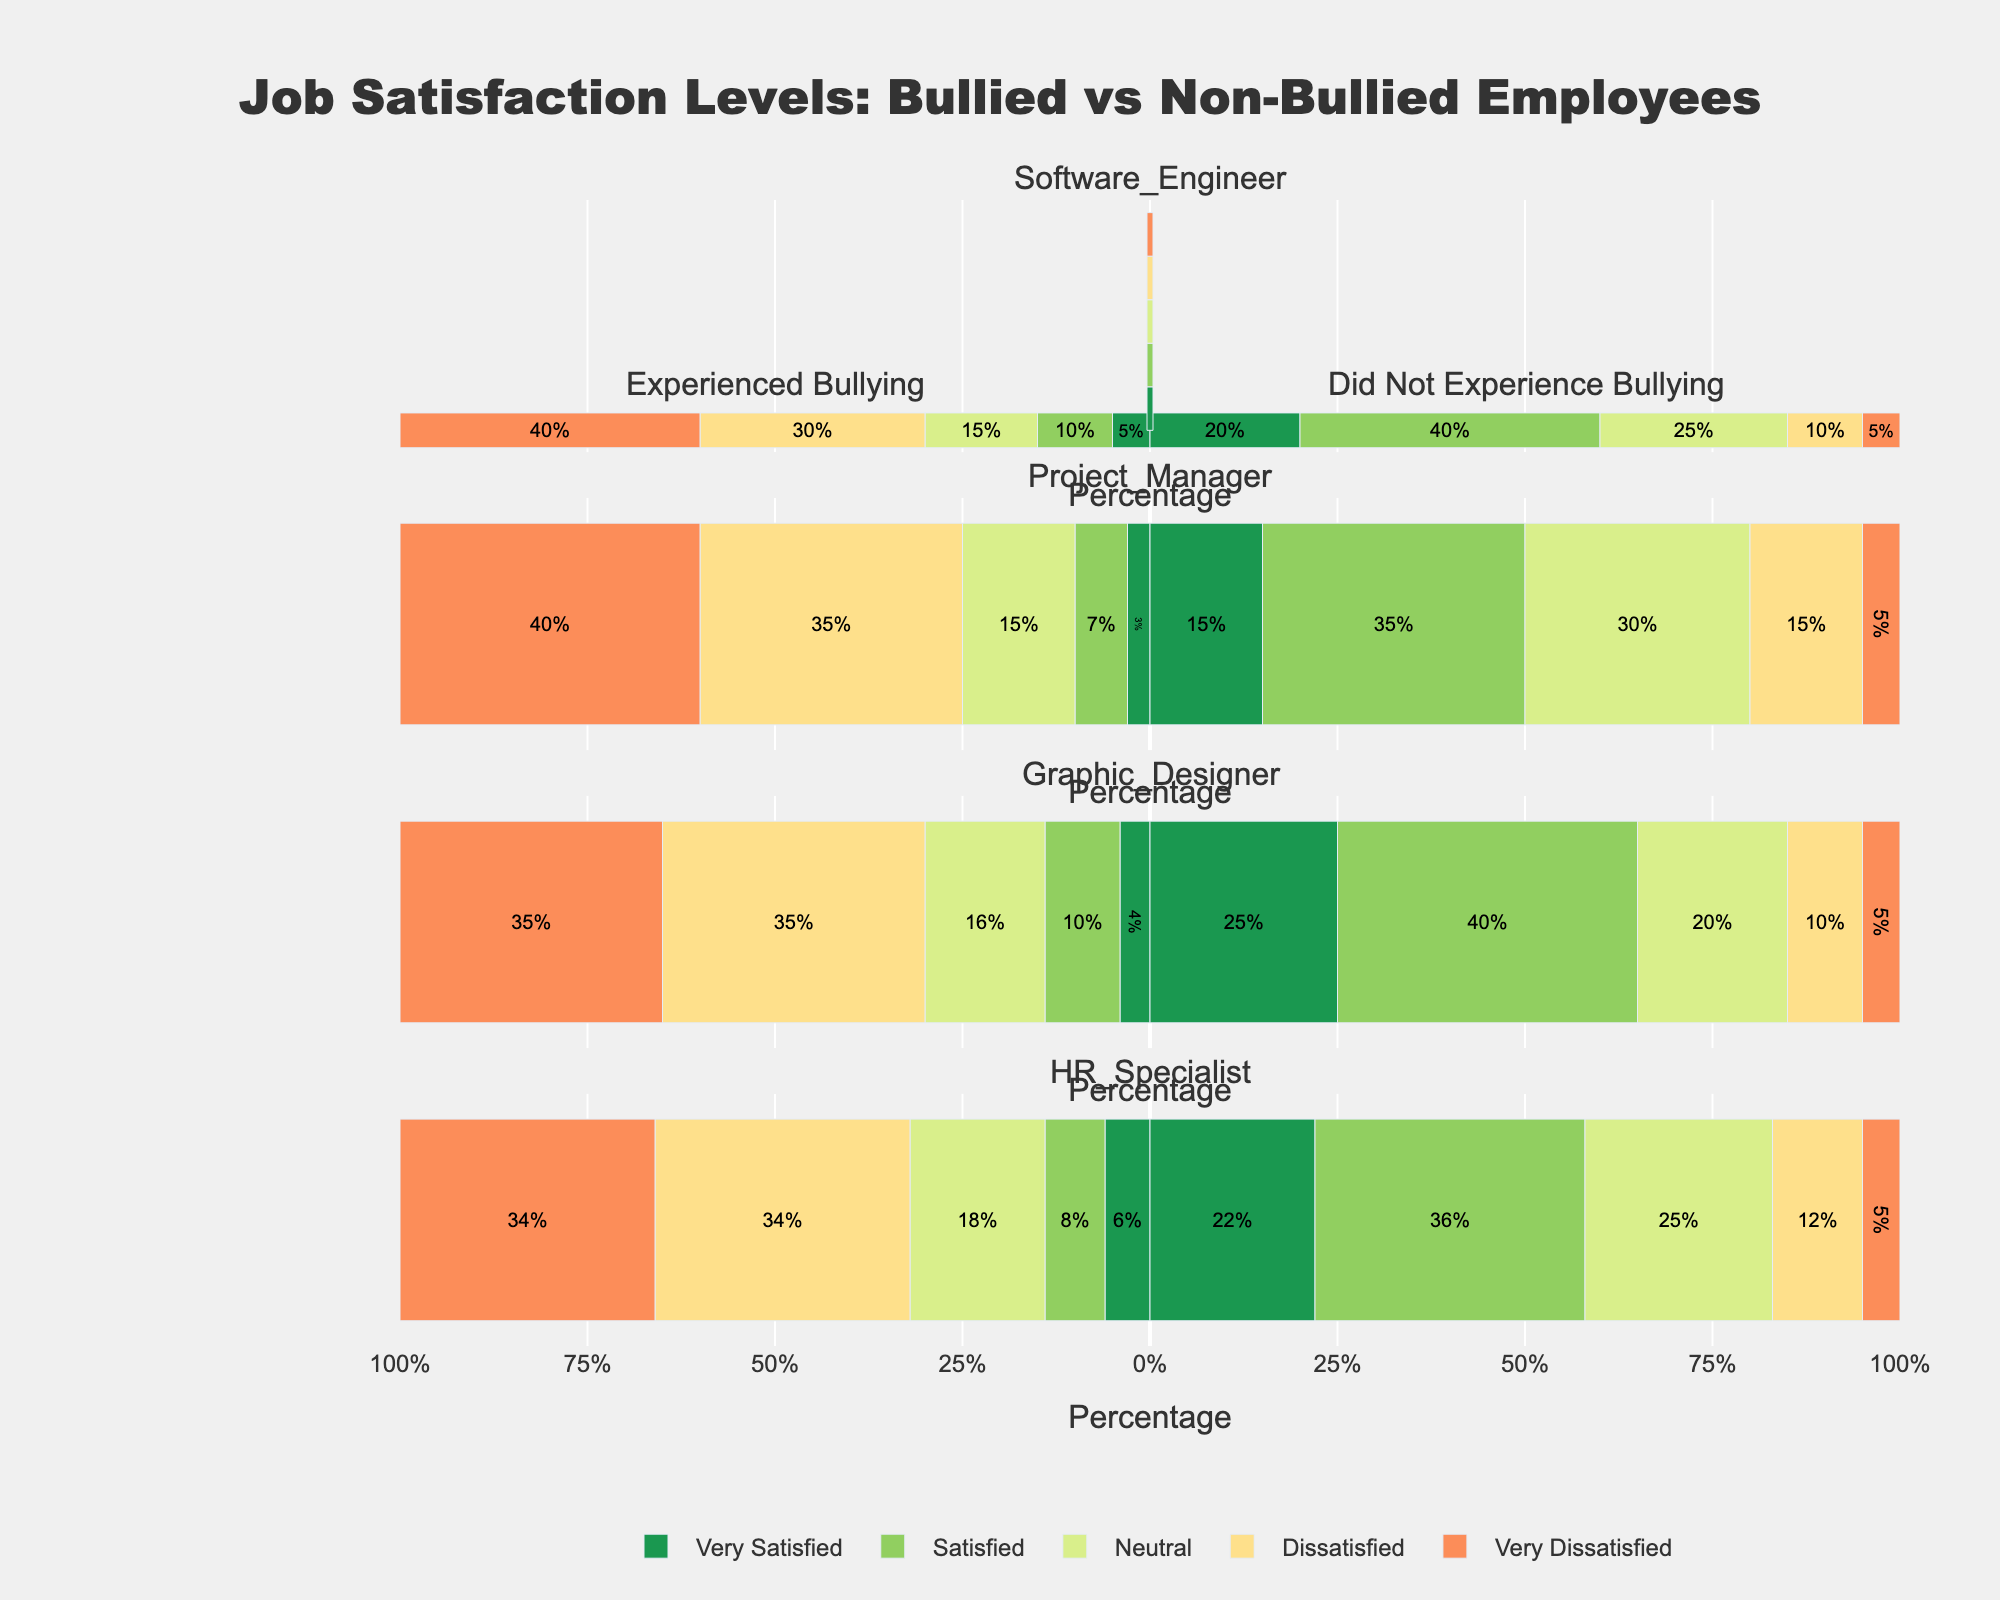What job role has the highest percentage of employees who are very dissatisfied and experienced bullying? The longest leftward bar for the "Very Dissatisfied" category indicates the highest percentage. For "Very Dissatisfied," the Software Engineer role has a 40% bar on the left side (bullying category).
Answer: Software Engineer Which job role has the highest percentage of employees who did not experience bullying and are very satisfied? The longest rightward bar for the "Very Satisfied" category indicates the highest percentage among non-bullied employees. The Graphic Designer role has a 25% bar on the right side (no bullying category).
Answer: Graphic Designer Compare the neutral satisfaction levels between bullied and non-bullied HR Specialists. For HR Specialists, the "Neutral" percentage is 18% on the left (bullying) and 25% on the right (no bullying). The non-bullied HR Specialists have a higher percentage of neutral satisfaction levels.
Answer: Non-bullied HR Specialists have higher neutral satisfaction What is the combined percentage of dissatisfied and very dissatisfied Software Engineers who experienced bullying? Sum the percentages of dissatisfied (30%) and very dissatisfied (40%) for bullied Software Engineers, which is 30 + 40 = 70%.
Answer: 70% For which job role do employees who did not experience bullying have the highest overall satisfaction (combined very satisfied and satisfied)? Check the bars for "Very Satisfied" and "Satisfied" in the no bullying category. The Graphic Designer role has a combined value of 25% + 40% = 65%.
Answer: Graphic Designer Which job role has the smallest percentage of very satisfied employees who experienced bullying? The shortest leftward bar for the "Very Satisfied" category indicates the smallest percentage. The Project Manager role has a 3% bar on the left side (bullying category).
Answer: Project Manager Compare the dissatisfied levels between bullied Project Managers and bullied Graphic Designers. For bullied Project Managers, the "Dissatisfied" percentage is 35%. For bullied Graphic Designers, the "Dissatisfied" percentage is the same, also 35%.
Answer: Bulled Project Managers and Graphic Designers have the same dissatisfied levels Which satisfaction level shows the most distinct difference between bullied and non-bullied Software Engineers? Look for the longest bars with the biggest visual gap between bullied and non-bullied categories. The "Very Satisfied" category has a significant difference (5% bullied vs. 20% non-bullied), a 15% difference.
Answer: Very Satisfied In terms of very dissatisfied, which group has the largest and the smallest percentage within any job role? The longest and shortest leftward bars for the "Very Dissatisfied" category show the highest and lowest percentages. The Software Engineer and Project Manager roles show the largest (40% bullied) and smallest consistent values among groups with 5% for non-bullied HR Specialists.
Answer: Largest: Software Engineer (40% bullied), Smallest: HR Specialist (5% non-bullied) 